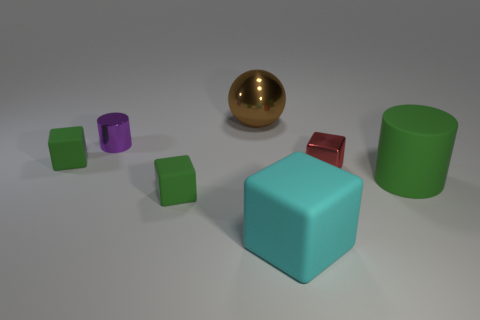The large rubber object that is the same shape as the red shiny object is what color? cyan 